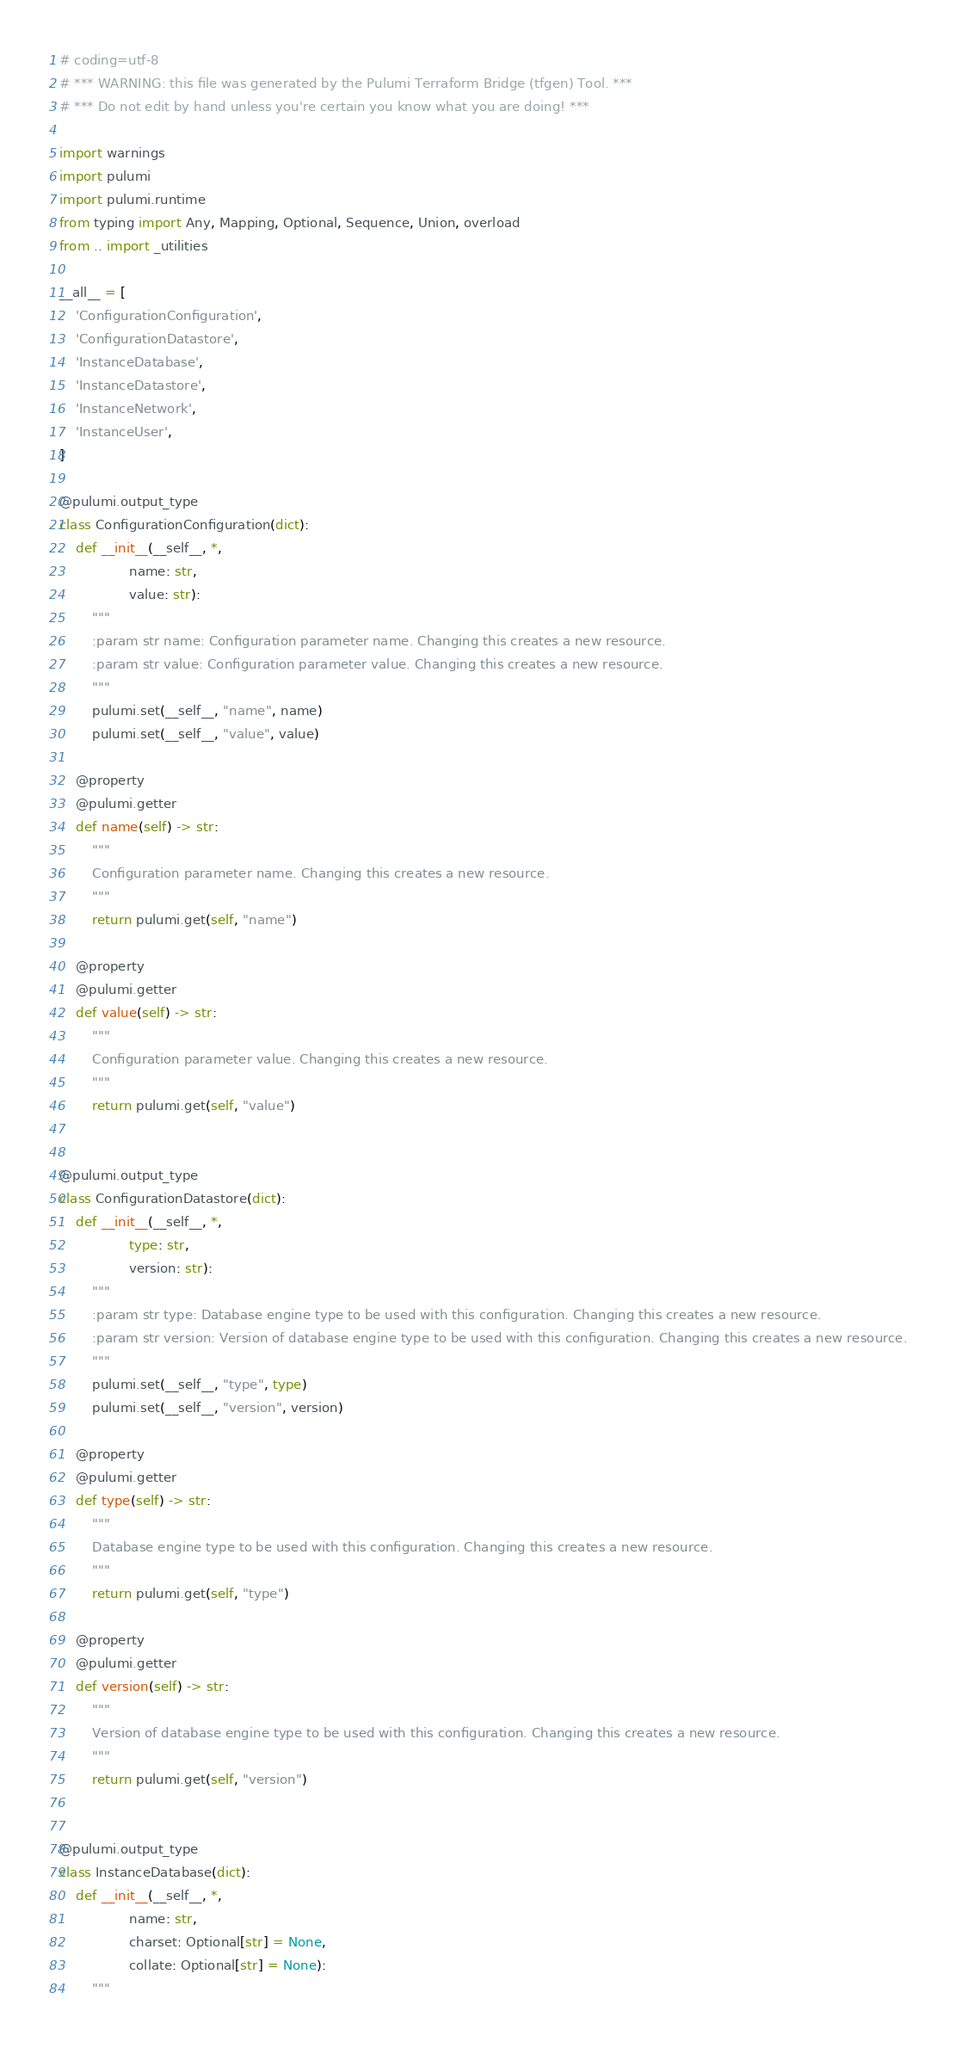Convert code to text. <code><loc_0><loc_0><loc_500><loc_500><_Python_># coding=utf-8
# *** WARNING: this file was generated by the Pulumi Terraform Bridge (tfgen) Tool. ***
# *** Do not edit by hand unless you're certain you know what you are doing! ***

import warnings
import pulumi
import pulumi.runtime
from typing import Any, Mapping, Optional, Sequence, Union, overload
from .. import _utilities

__all__ = [
    'ConfigurationConfiguration',
    'ConfigurationDatastore',
    'InstanceDatabase',
    'InstanceDatastore',
    'InstanceNetwork',
    'InstanceUser',
]

@pulumi.output_type
class ConfigurationConfiguration(dict):
    def __init__(__self__, *,
                 name: str,
                 value: str):
        """
        :param str name: Configuration parameter name. Changing this creates a new resource.
        :param str value: Configuration parameter value. Changing this creates a new resource.
        """
        pulumi.set(__self__, "name", name)
        pulumi.set(__self__, "value", value)

    @property
    @pulumi.getter
    def name(self) -> str:
        """
        Configuration parameter name. Changing this creates a new resource.
        """
        return pulumi.get(self, "name")

    @property
    @pulumi.getter
    def value(self) -> str:
        """
        Configuration parameter value. Changing this creates a new resource.
        """
        return pulumi.get(self, "value")


@pulumi.output_type
class ConfigurationDatastore(dict):
    def __init__(__self__, *,
                 type: str,
                 version: str):
        """
        :param str type: Database engine type to be used with this configuration. Changing this creates a new resource.
        :param str version: Version of database engine type to be used with this configuration. Changing this creates a new resource.
        """
        pulumi.set(__self__, "type", type)
        pulumi.set(__self__, "version", version)

    @property
    @pulumi.getter
    def type(self) -> str:
        """
        Database engine type to be used with this configuration. Changing this creates a new resource.
        """
        return pulumi.get(self, "type")

    @property
    @pulumi.getter
    def version(self) -> str:
        """
        Version of database engine type to be used with this configuration. Changing this creates a new resource.
        """
        return pulumi.get(self, "version")


@pulumi.output_type
class InstanceDatabase(dict):
    def __init__(__self__, *,
                 name: str,
                 charset: Optional[str] = None,
                 collate: Optional[str] = None):
        """</code> 